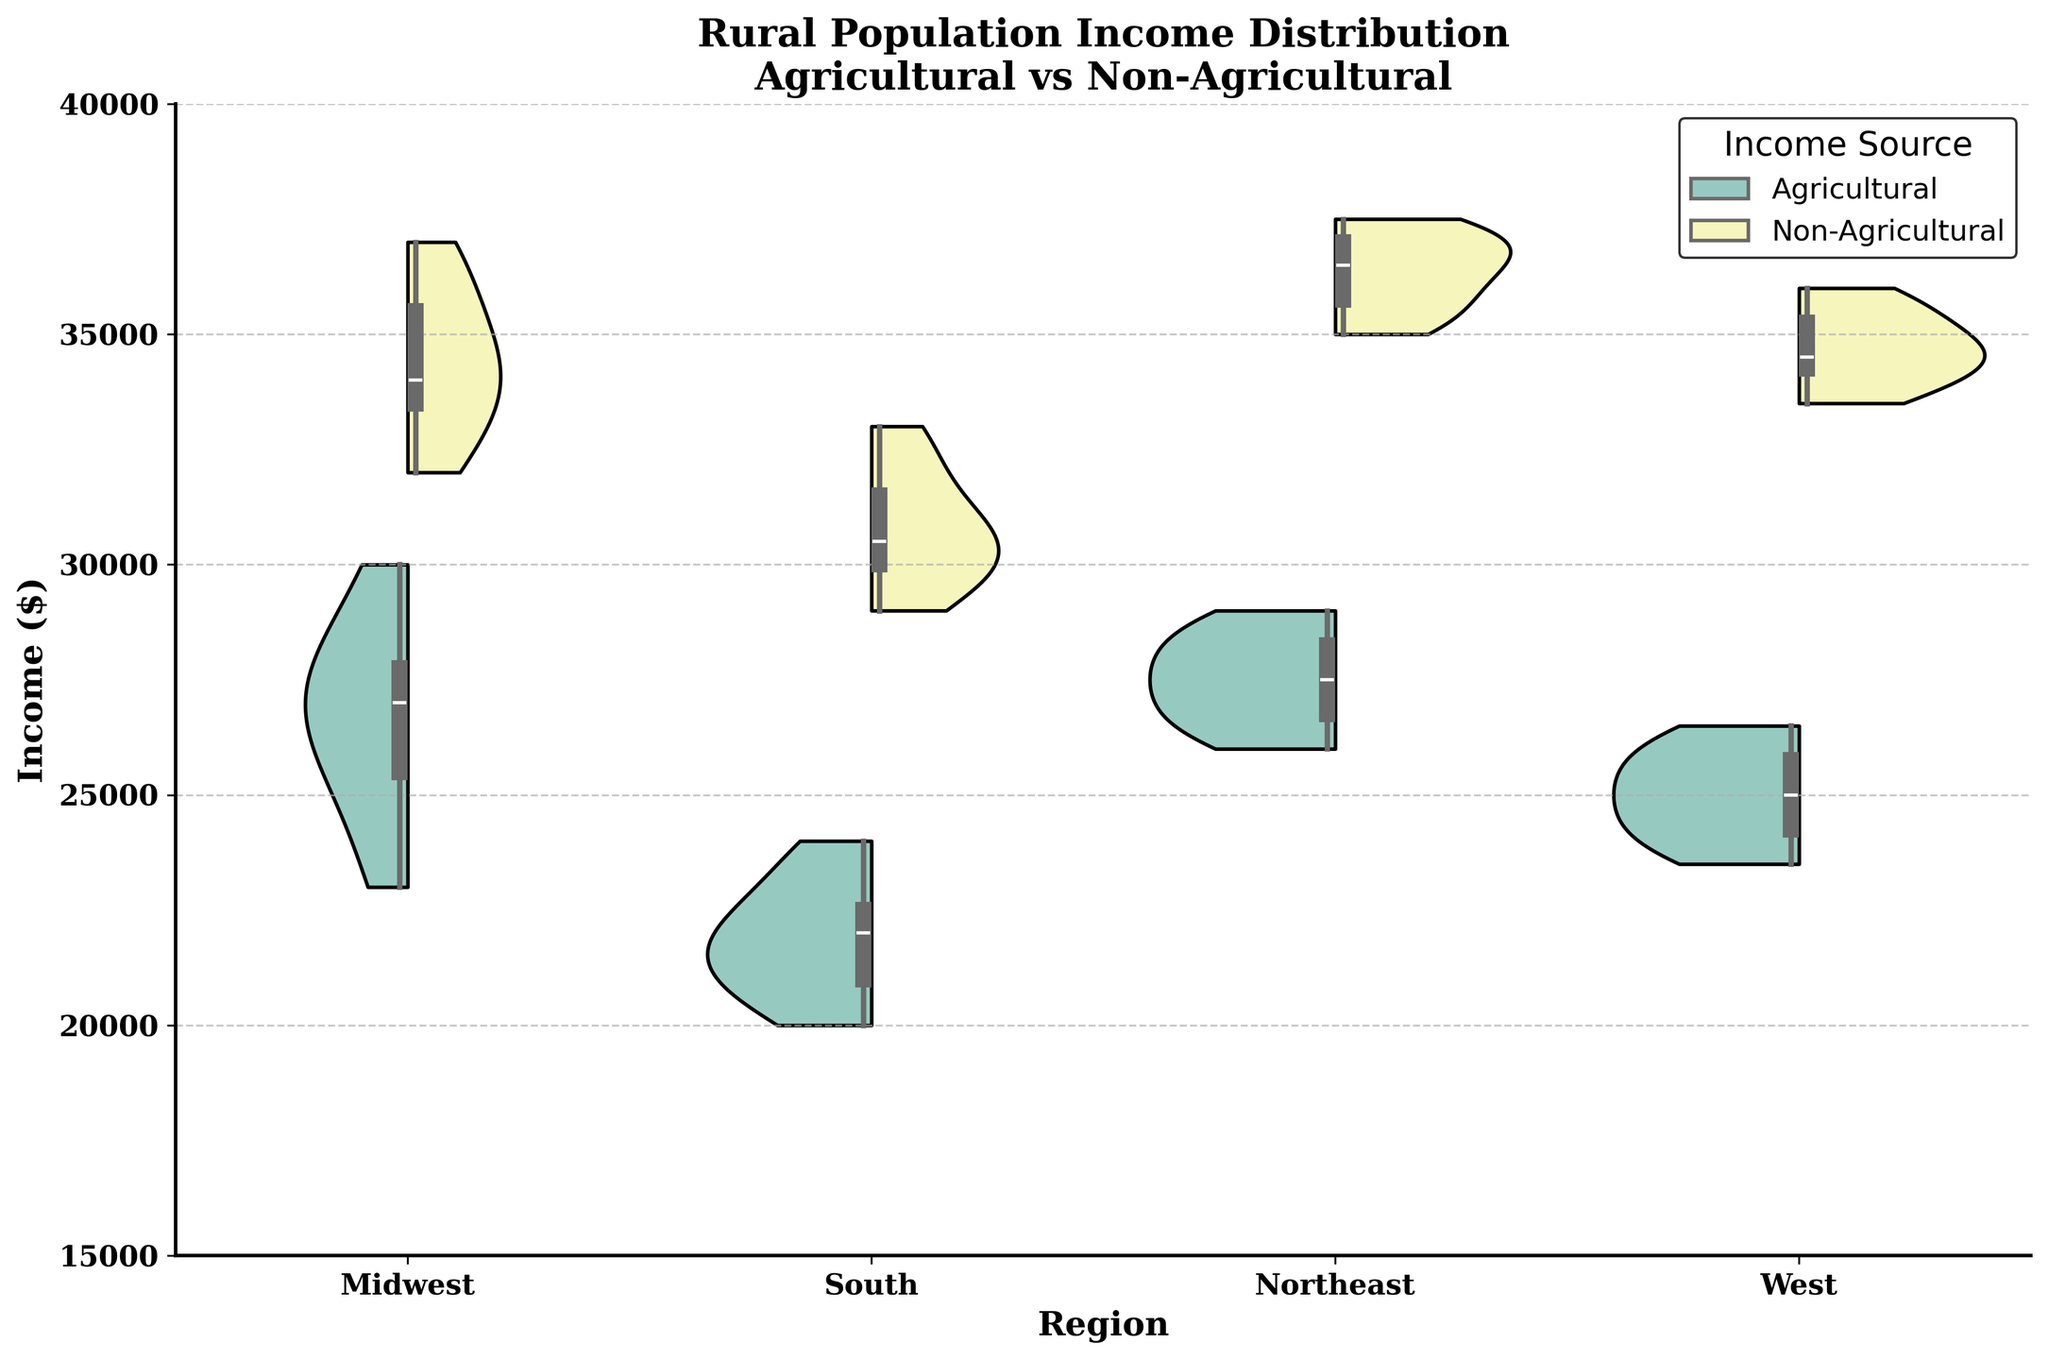What is the title of the figure? The title is located at the top of the figure, and it reads "Rural Population Income Distribution Agricultural vs Non-Agricultural."
Answer: Rural Population Income Distribution Agricultural vs Non-Agricultural What is the range of the y-axis? The y-axis shows the range of income values which spans from $15,000 to $40,000.
Answer: $15,000 to $40,000 How does the median Agricultural income in the Midwest compare to the Non-Agricultural income in the Midwest? The median is represented by the white dot within the box plot. In the Midwest, the median Agricultural income is lower compared to the median Non-Agricultural income.
Answer: Lower Which region shows the widest income distribution for Agricultural income? The widest distribution can be observed by looking at the spread of the violin plot. The Midwest shows the widest spread for Agricultural income based on the width and spread of the violin plot.
Answer: Midwest What is the main color used to represent Non-Agricultural income? The color representing Non-Agricultural income is visible in the legend or the plot itself. It is a pinkish-orange color.
Answer: Pinkish-orange In which region is the median Non-Agricultural income the highest? The median income is represented by the white dot in the box plot. The highest median Non-Agricultural income is in the Northeast.
Answer: Northeast Compare the spread of Agricultural incomes in the South and the West. Which is narrower? The spread can be observed from the width of the violin plot. The South has a narrower spread compared to the West.
Answer: South Which category has a higher maximum income in the Northeast region? The maximum income can be observed at the top end of the violin plot. In the Northeast, the Non-Agricultural category has a higher maximum income.
Answer: Non-Agricultural How does the median Agricultural income in the Northeast compare to the Agricultural income in the West? The median income is represented by the white dot within the box plot. The median Agricultural income in the Northeast is higher than in the West.
Answer: Higher In the West, which category shows greater variability in income? Variability in income can be observed by looking at the spread of the violin plot. In the West, the Non-Agricultural category shows greater variability.
Answer: Non-Agricultural 